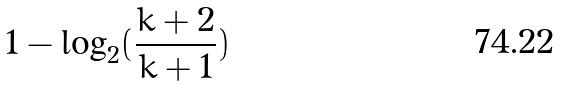<formula> <loc_0><loc_0><loc_500><loc_500>1 - \log _ { 2 } ( \frac { k + 2 } { k + 1 } )</formula> 